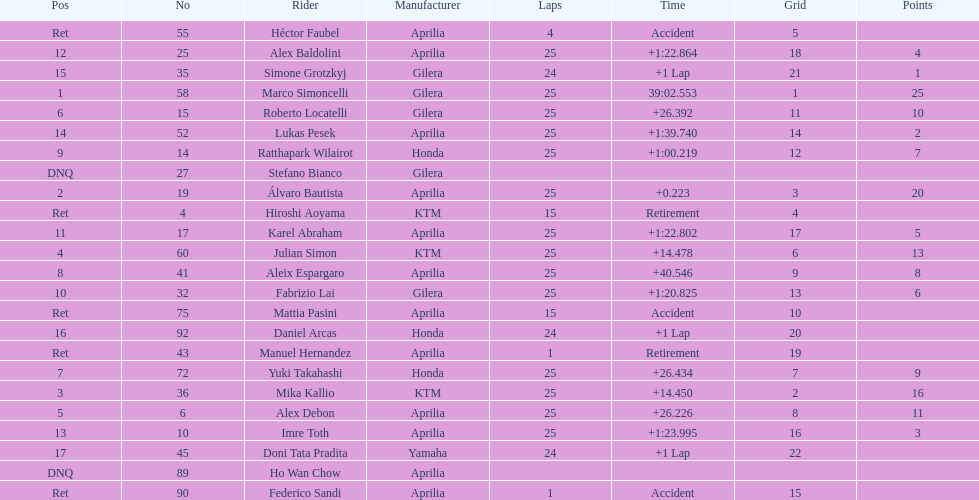What is the total number of laps performed by rider imre toth? 25. Could you help me parse every detail presented in this table? {'header': ['Pos', 'No', 'Rider', 'Manufacturer', 'Laps', 'Time', 'Grid', 'Points'], 'rows': [['Ret', '55', 'Héctor Faubel', 'Aprilia', '4', 'Accident', '5', ''], ['12', '25', 'Alex Baldolini', 'Aprilia', '25', '+1:22.864', '18', '4'], ['15', '35', 'Simone Grotzkyj', 'Gilera', '24', '+1 Lap', '21', '1'], ['1', '58', 'Marco Simoncelli', 'Gilera', '25', '39:02.553', '1', '25'], ['6', '15', 'Roberto Locatelli', 'Gilera', '25', '+26.392', '11', '10'], ['14', '52', 'Lukas Pesek', 'Aprilia', '25', '+1:39.740', '14', '2'], ['9', '14', 'Ratthapark Wilairot', 'Honda', '25', '+1:00.219', '12', '7'], ['DNQ', '27', 'Stefano Bianco', 'Gilera', '', '', '', ''], ['2', '19', 'Álvaro Bautista', 'Aprilia', '25', '+0.223', '3', '20'], ['Ret', '4', 'Hiroshi Aoyama', 'KTM', '15', 'Retirement', '4', ''], ['11', '17', 'Karel Abraham', 'Aprilia', '25', '+1:22.802', '17', '5'], ['4', '60', 'Julian Simon', 'KTM', '25', '+14.478', '6', '13'], ['8', '41', 'Aleix Espargaro', 'Aprilia', '25', '+40.546', '9', '8'], ['10', '32', 'Fabrizio Lai', 'Gilera', '25', '+1:20.825', '13', '6'], ['Ret', '75', 'Mattia Pasini', 'Aprilia', '15', 'Accident', '10', ''], ['16', '92', 'Daniel Arcas', 'Honda', '24', '+1 Lap', '20', ''], ['Ret', '43', 'Manuel Hernandez', 'Aprilia', '1', 'Retirement', '19', ''], ['7', '72', 'Yuki Takahashi', 'Honda', '25', '+26.434', '7', '9'], ['3', '36', 'Mika Kallio', 'KTM', '25', '+14.450', '2', '16'], ['5', '6', 'Alex Debon', 'Aprilia', '25', '+26.226', '8', '11'], ['13', '10', 'Imre Toth', 'Aprilia', '25', '+1:23.995', '16', '3'], ['17', '45', 'Doni Tata Pradita', 'Yamaha', '24', '+1 Lap', '22', ''], ['DNQ', '89', 'Ho Wan Chow', 'Aprilia', '', '', '', ''], ['Ret', '90', 'Federico Sandi', 'Aprilia', '1', 'Accident', '15', '']]} 